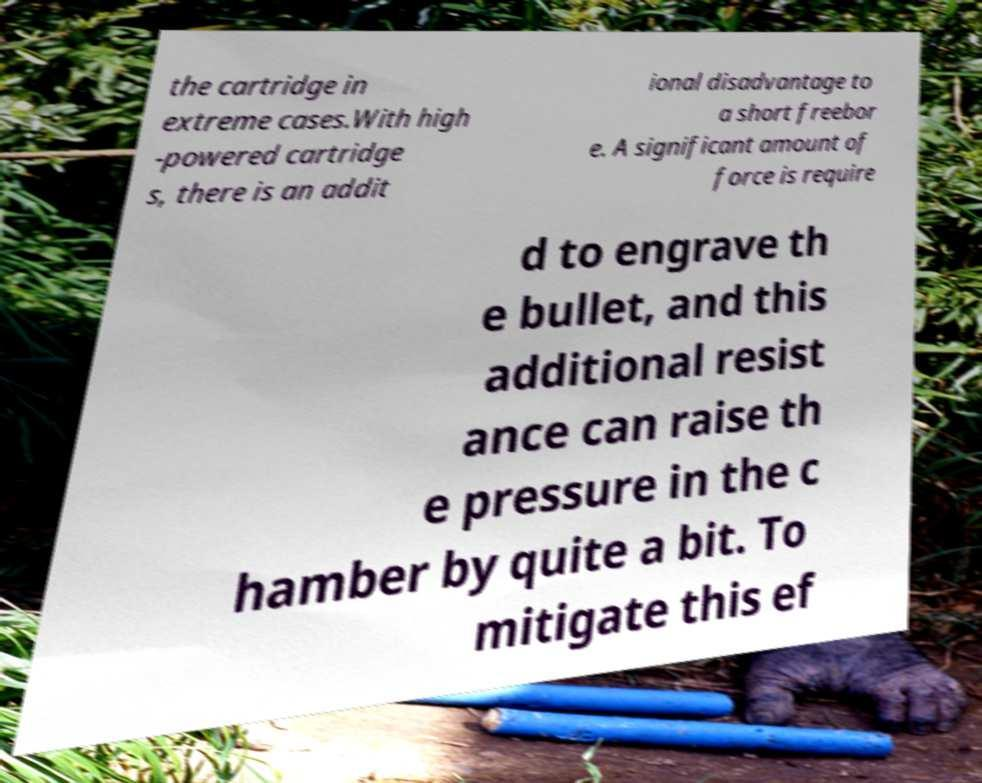Can you read and provide the text displayed in the image?This photo seems to have some interesting text. Can you extract and type it out for me? the cartridge in extreme cases.With high -powered cartridge s, there is an addit ional disadvantage to a short freebor e. A significant amount of force is require d to engrave th e bullet, and this additional resist ance can raise th e pressure in the c hamber by quite a bit. To mitigate this ef 